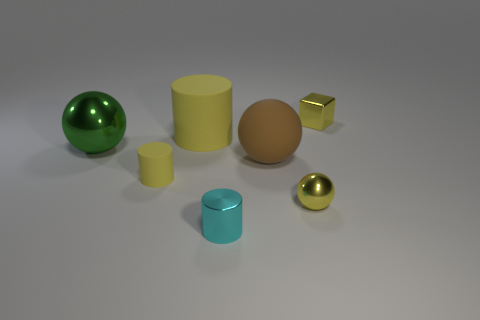The yellow metallic object that is on the left side of the yellow thing on the right side of the small metal sphere is what shape?
Offer a very short reply. Sphere. Is the material of the tiny yellow thing behind the big green metal ball the same as the cylinder that is behind the large metallic ball?
Provide a succinct answer. No. There is a tiny object in front of the small yellow metallic sphere; what number of tiny cyan metallic cylinders are right of it?
Your answer should be very brief. 0. There is a small yellow shiny thing that is behind the big brown matte thing; does it have the same shape as the small shiny thing that is to the left of the big brown ball?
Make the answer very short. No. There is a thing that is both in front of the big green object and left of the tiny cyan cylinder; what size is it?
Offer a very short reply. Small. The other rubber thing that is the same shape as the green thing is what color?
Keep it short and to the point. Brown. What is the color of the small cylinder that is to the left of the shiny cylinder on the right side of the tiny matte cylinder?
Offer a very short reply. Yellow. The brown object is what shape?
Your answer should be compact. Sphere. The tiny metallic thing that is both right of the tiny cyan object and in front of the small yellow rubber object has what shape?
Give a very brief answer. Sphere. What is the color of the small cylinder that is the same material as the yellow sphere?
Offer a terse response. Cyan. 